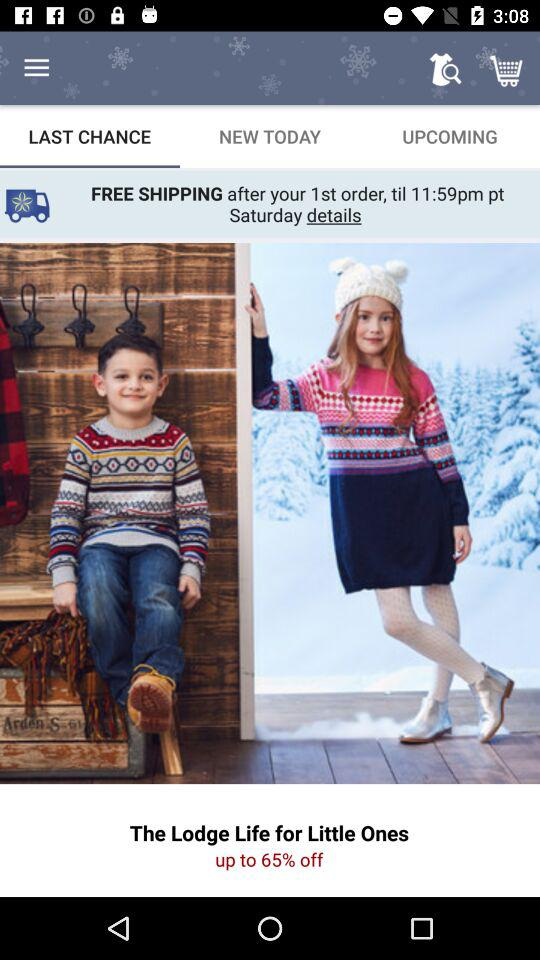How much is the discount off the Lodge Life for Little Ones product?
Answer the question using a single word or phrase. 65% 